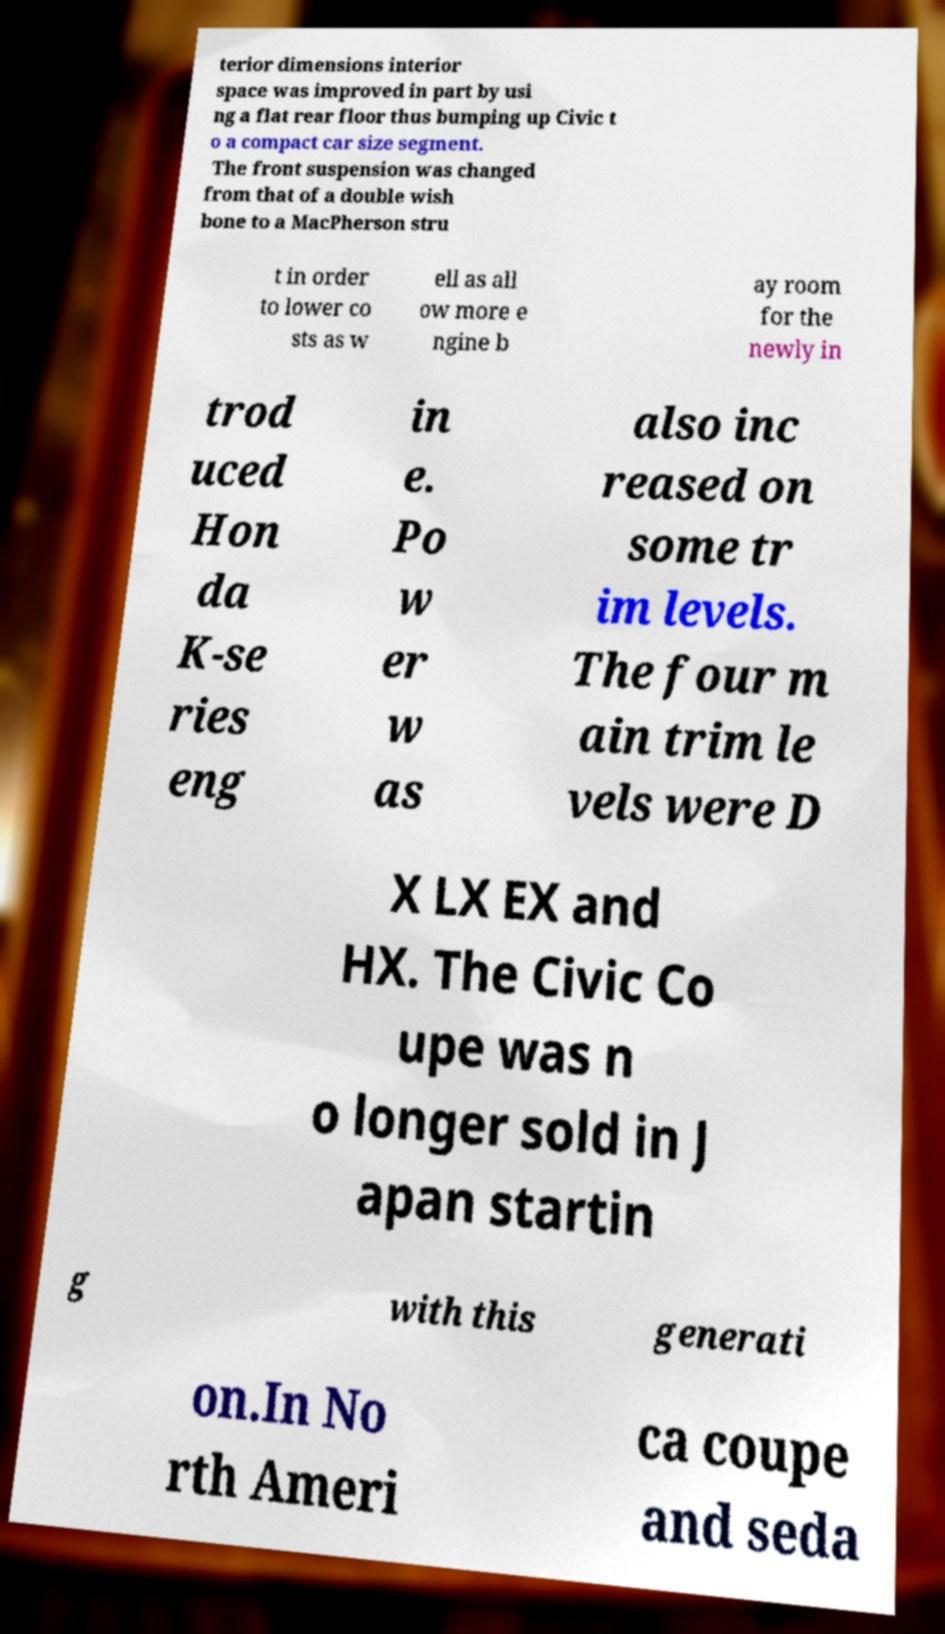What messages or text are displayed in this image? I need them in a readable, typed format. terior dimensions interior space was improved in part by usi ng a flat rear floor thus bumping up Civic t o a compact car size segment. The front suspension was changed from that of a double wish bone to a MacPherson stru t in order to lower co sts as w ell as all ow more e ngine b ay room for the newly in trod uced Hon da K-se ries eng in e. Po w er w as also inc reased on some tr im levels. The four m ain trim le vels were D X LX EX and HX. The Civic Co upe was n o longer sold in J apan startin g with this generati on.In No rth Ameri ca coupe and seda 